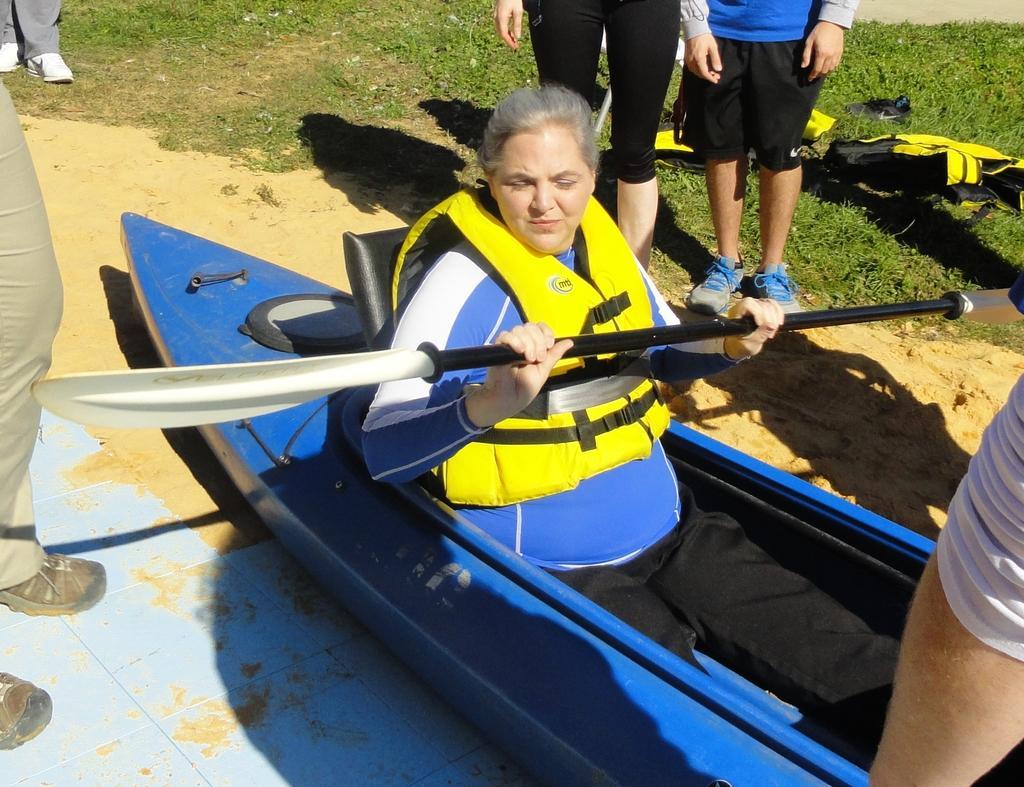Could you give a brief overview of what you see in this image? A person is sitting on a boat and holding paddle. There are other people and grass. 